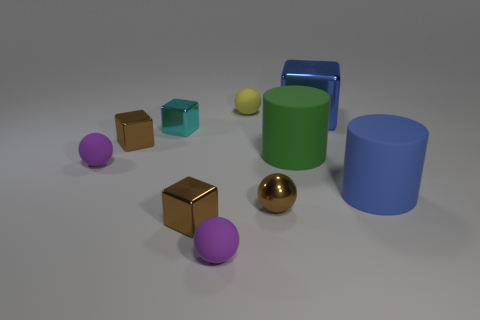There is a big shiny object that is the same shape as the small cyan object; what color is it?
Make the answer very short. Blue. What shape is the yellow thing that is the same size as the cyan metallic thing?
Provide a succinct answer. Sphere. What is the shape of the small purple matte thing that is behind the rubber cylinder to the right of the large blue thing behind the tiny cyan object?
Your answer should be compact. Sphere. Do the big metal thing and the blue object in front of the green cylinder have the same shape?
Offer a terse response. No. What number of large things are blue cylinders or cubes?
Make the answer very short. 2. Is there a cyan shiny ball that has the same size as the brown metal ball?
Your answer should be very brief. No. What color is the small shiny thing on the right side of the purple matte ball in front of the tiny metal cube in front of the brown ball?
Offer a very short reply. Brown. Do the tiny yellow thing and the small cyan object that is in front of the big blue shiny cube have the same material?
Offer a terse response. No. What size is the other matte object that is the same shape as the big green object?
Provide a short and direct response. Large. Are there an equal number of large blue metal cubes behind the blue metallic object and small blocks that are in front of the cyan cube?
Make the answer very short. No. 